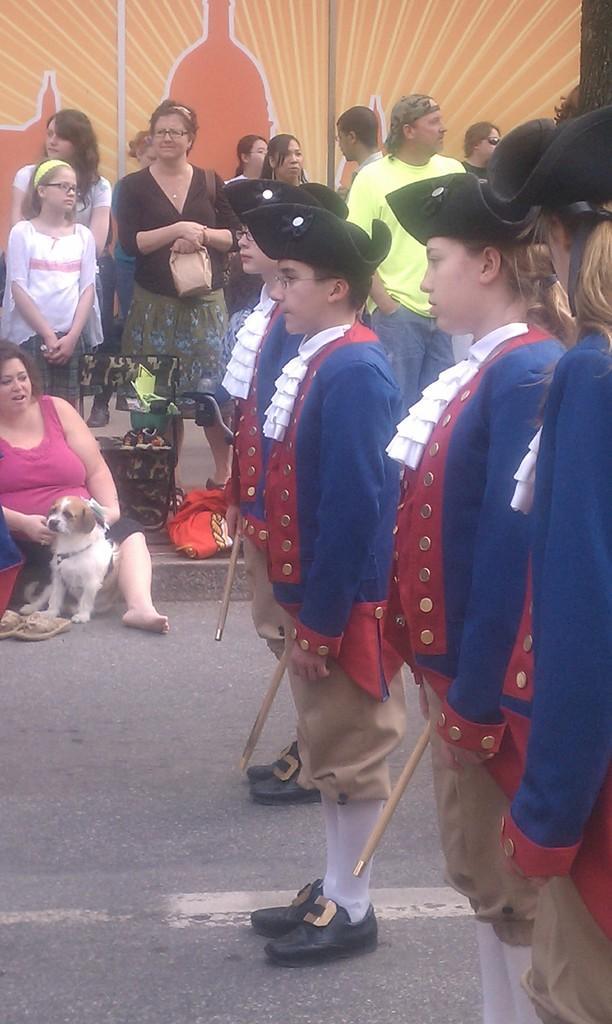How would you summarize this image in a sentence or two? This picture shows group of people standing and a woman seated holding a dog in her hand. 